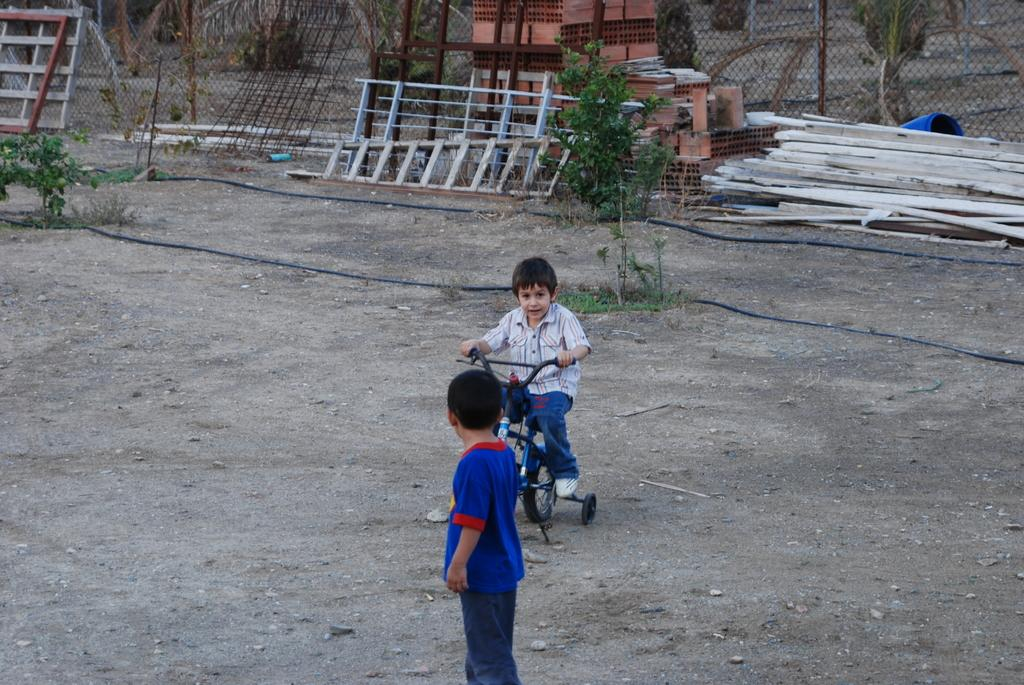What is the main activity of the boy in the image? The boy is riding a bicycle on the ground. How is the other boy in the image interacting with the scene? The other boy is looking at the boy riding the bicycle. What can be seen in the background of the image? In the background, there are ladders, wooden material, a fence, rods, a tree, and drums. Where is the desk located in the image? There is no desk present in the image. How does the boy riding the bicycle test his skills in the image? The image does not show the boy testing any skills; he is simply riding a bicycle. 